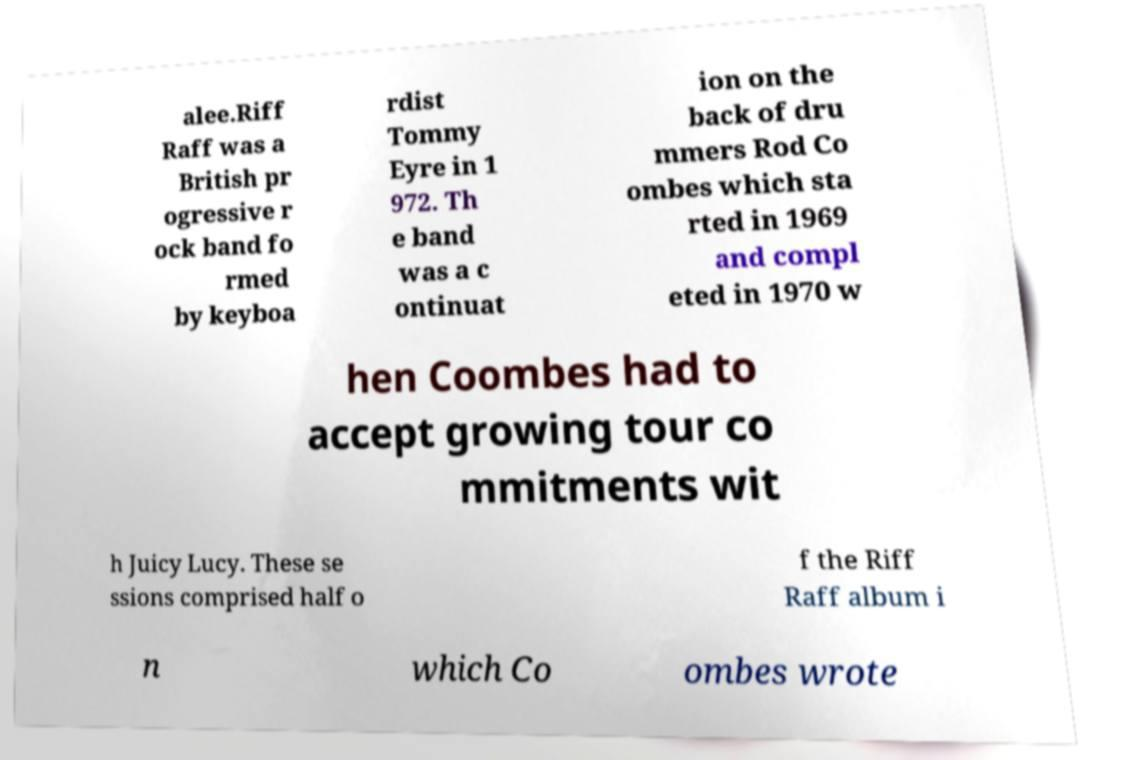For documentation purposes, I need the text within this image transcribed. Could you provide that? alee.Riff Raff was a British pr ogressive r ock band fo rmed by keyboa rdist Tommy Eyre in 1 972. Th e band was a c ontinuat ion on the back of dru mmers Rod Co ombes which sta rted in 1969 and compl eted in 1970 w hen Coombes had to accept growing tour co mmitments wit h Juicy Lucy. These se ssions comprised half o f the Riff Raff album i n which Co ombes wrote 